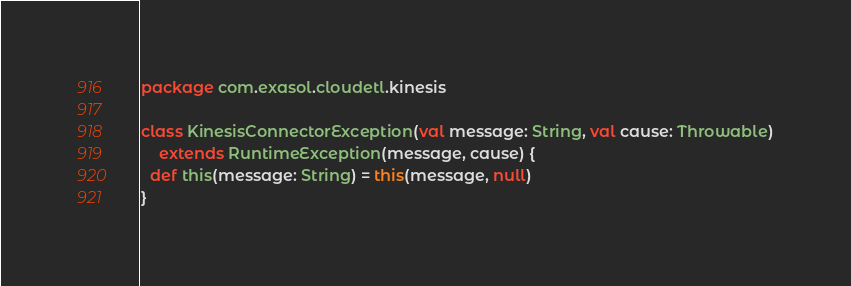<code> <loc_0><loc_0><loc_500><loc_500><_Scala_>package com.exasol.cloudetl.kinesis

class KinesisConnectorException(val message: String, val cause: Throwable)
    extends RuntimeException(message, cause) {
  def this(message: String) = this(message, null)
}
</code> 